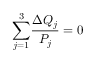Convert formula to latex. <formula><loc_0><loc_0><loc_500><loc_500>{ \sum _ { j = 1 } ^ { 3 } } \frac { \Delta Q _ { j } } { P _ { j } } = 0</formula> 